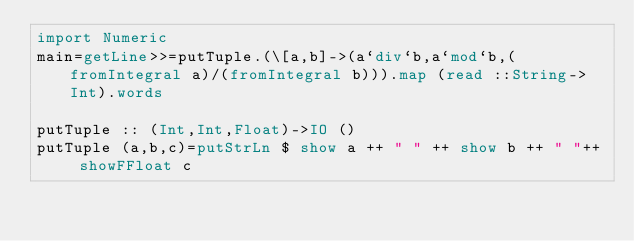<code> <loc_0><loc_0><loc_500><loc_500><_Haskell_>import Numeric
main=getLine>>=putTuple.(\[a,b]->(a`div`b,a`mod`b,(fromIntegral a)/(fromIntegral b))).map (read ::String->Int).words

putTuple :: (Int,Int,Float)->IO ()
putTuple (a,b,c)=putStrLn $ show a ++ " " ++ show b ++ " "++ showFFloat c
 </code> 